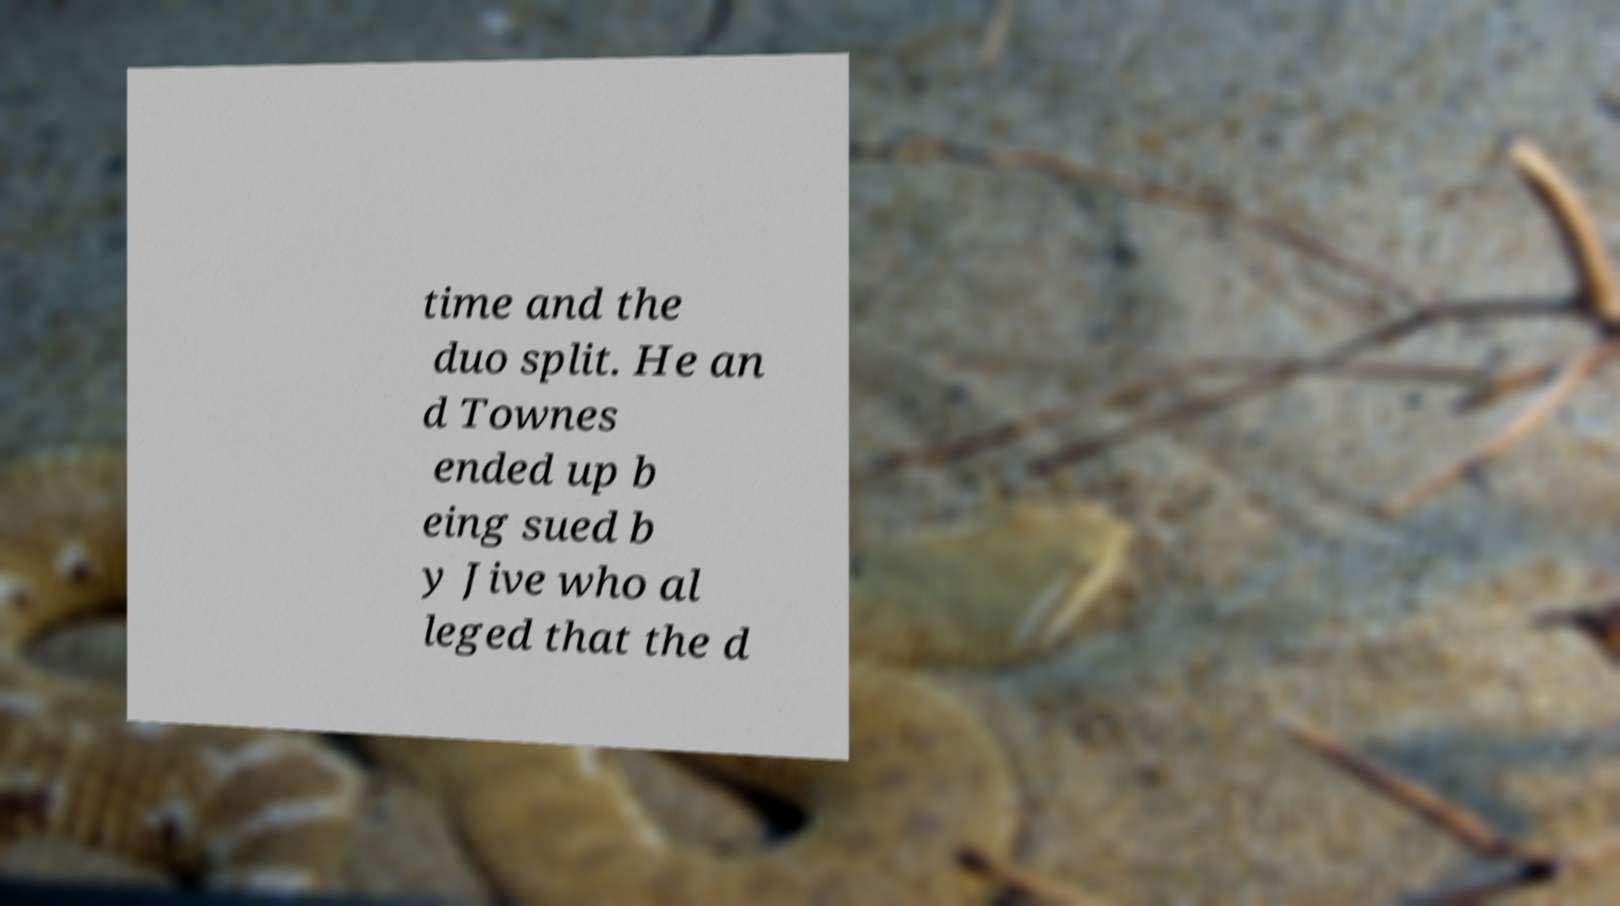I need the written content from this picture converted into text. Can you do that? time and the duo split. He an d Townes ended up b eing sued b y Jive who al leged that the d 